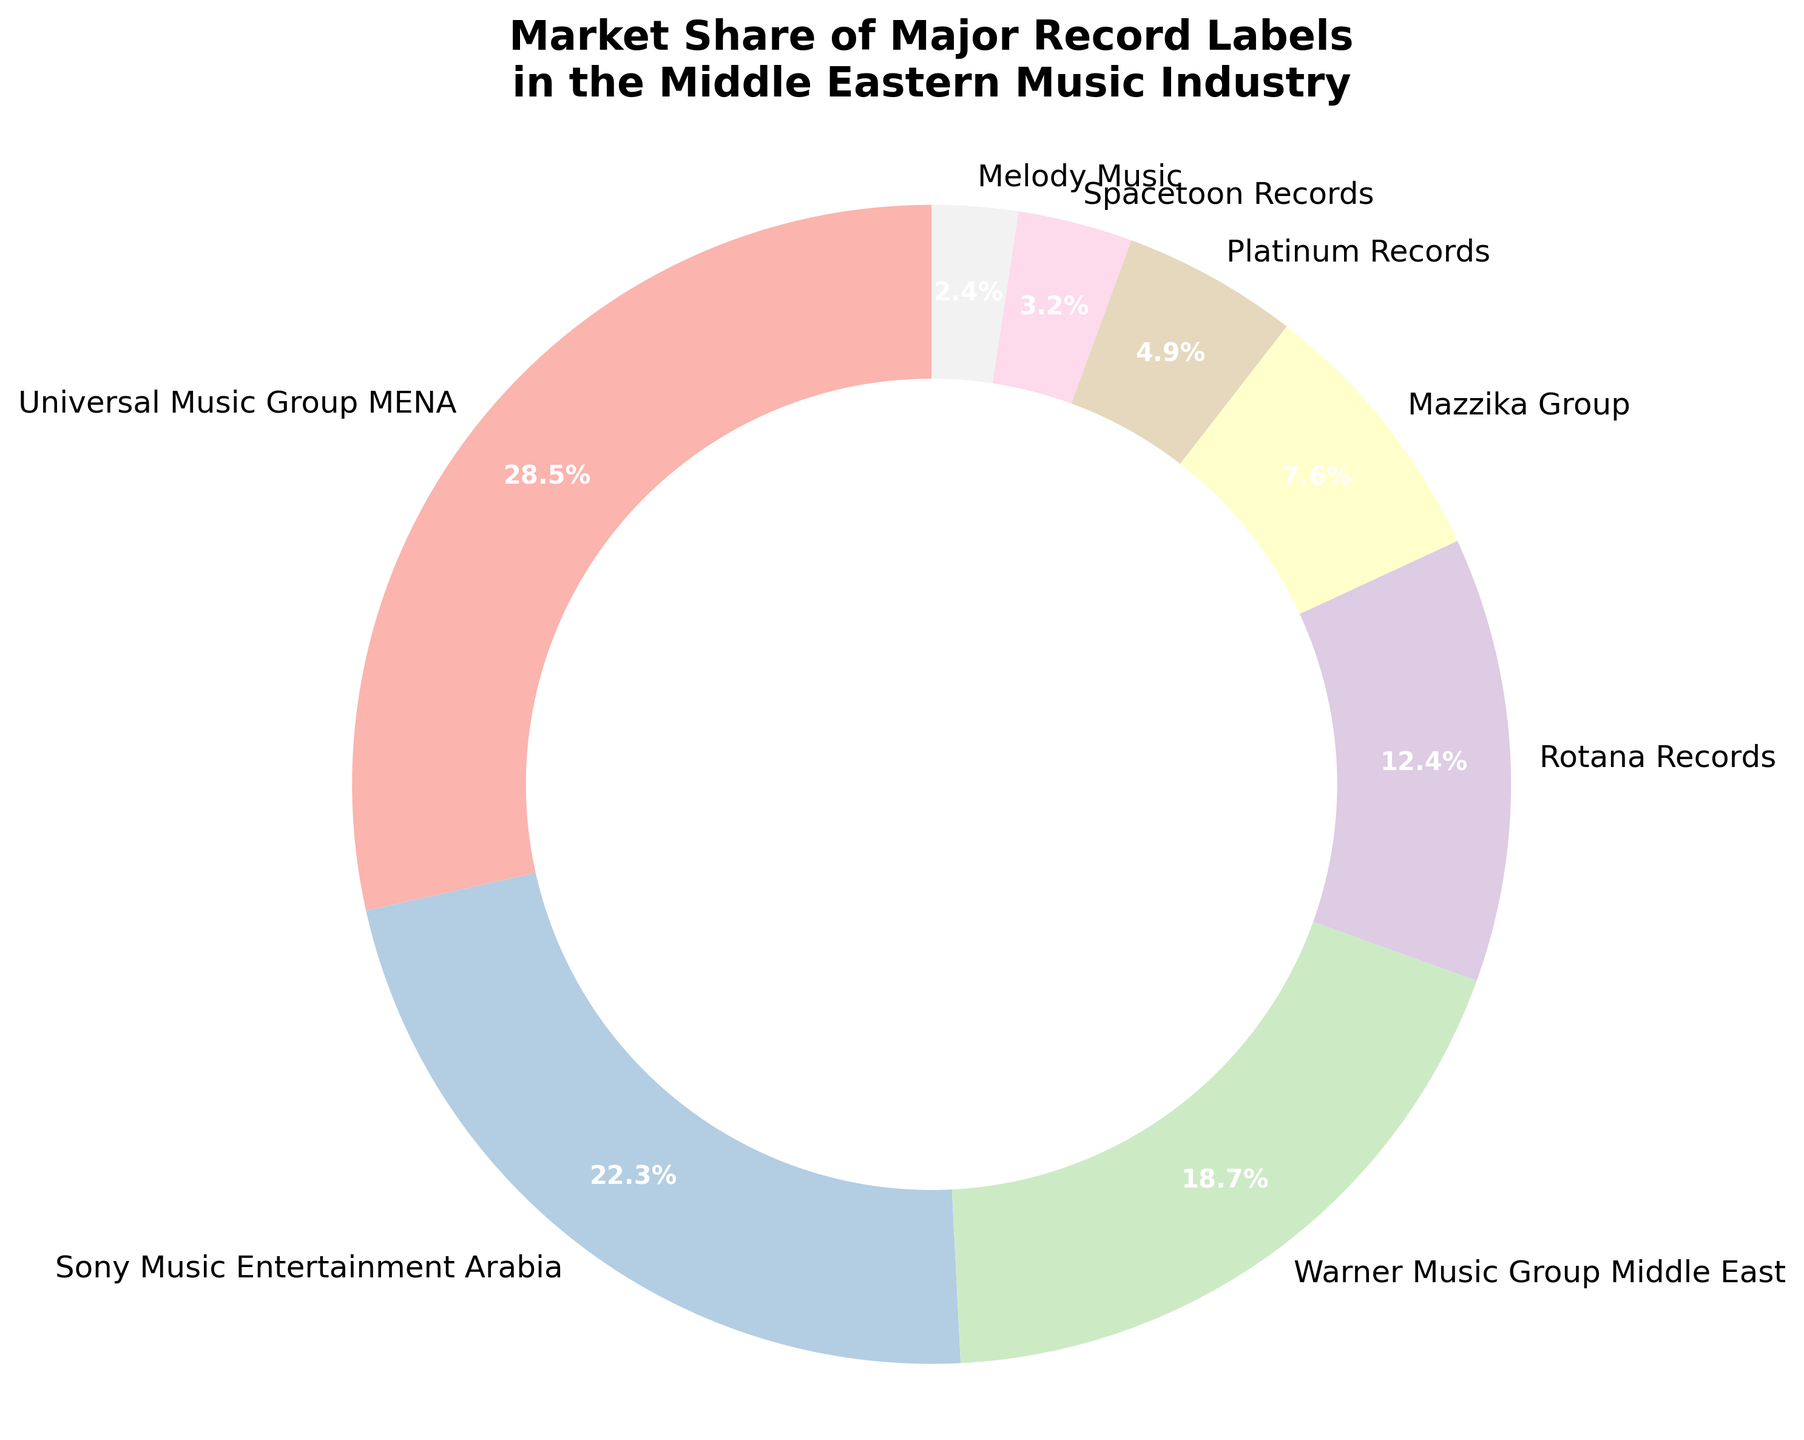What is the market share of Universal Music Group MENA? Universal Music Group MENA has a market share of 28.5%. This is directly visible in the pie chart section labeled "Universal Music Group MENA".
Answer: 28.5% Which label has the smallest market share? The smallest market share is represented by Melody Music, which is 2.4%. This can be seen by finding the smallest slice in the pie chart.
Answer: Melody Music What is the total market share of the top three labels? The top three labels are Universal Music Group MENA (28.5%), Sony Music Entertainment Arabia (22.3%), and Warner Music Group Middle East (18.7%). Summing these percentages: 28.5 + 22.3 + 18.7 = 69.5%.
Answer: 69.5% How much more market share does Universal Music Group MENA have compared to Rotana Records? Universal Music Group MENA has a market share of 28.5% while Rotana Records has 12.4%. Subtracting these: 28.5 - 12.4 = 16.1%.
Answer: 16.1% Which labels have a market share greater than 10%? The labels with market shares greater than 10% are Universal Music Group MENA (28.5%), Sony Music Entertainment Arabia (22.3%), Warner Music Group Middle East (18.7%), and Rotana Records (12.4%). This can be seen by identifying all slices in the pie chart with percentages greater than 10%.
Answer: Universal Music Group MENA, Sony Music Entertainment Arabia, Warner Music Group Middle East, Rotana Records Are the top three labels' combined market share greater than half of the entire market? The top three labels' combined market share is 69.5%. Since 69.5% is greater than 50%, they collectively hold more than half of the market.
Answer: Yes What is the total market share of labels with less than 10% share each? The labels with less than 10% share each are Mazzika Group (7.6%), Platinum Records (4.9%), Spacetoon Records (3.2%), and Melody Music (2.4%). Summing these: 7.6 + 4.9 + 3.2 + 2.4 = 18.1%.
Answer: 18.1% Which label has the closest market share to 20%? The label closest to 20% is Sony Music Entertainment Arabia with a market share of 22.3%. This is the nearest value to 20% when compared to the other slices in the pie chart.
Answer: Sony Music Entertainment Arabia How much combined market share do Rotana Records and Mazzika Group have? Rotana Records has a market share of 12.4%, and Mazzika Group has a share of 7.6%. Their combined share is 12.4 + 7.6 = 20%.
Answer: 20% What is the difference in market share between the label with the highest and the label with the lowest share? The highest market share is Universal Music Group MENA with 28.5%, and the lowest is Melody Music with 2.4%. The difference is 28.5 - 2.4 = 26.1%.
Answer: 26.1% 